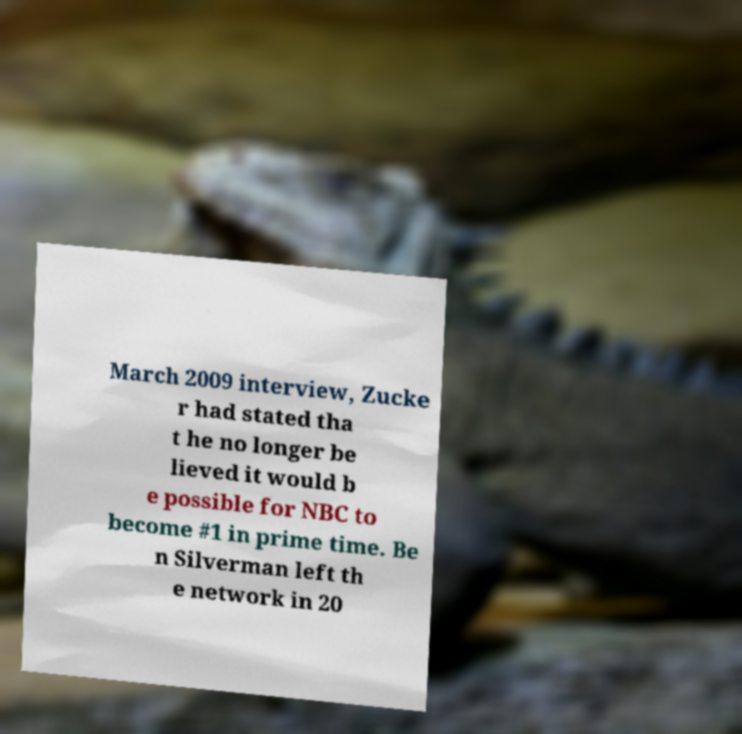Please read and relay the text visible in this image. What does it say? March 2009 interview, Zucke r had stated tha t he no longer be lieved it would b e possible for NBC to become #1 in prime time. Be n Silverman left th e network in 20 